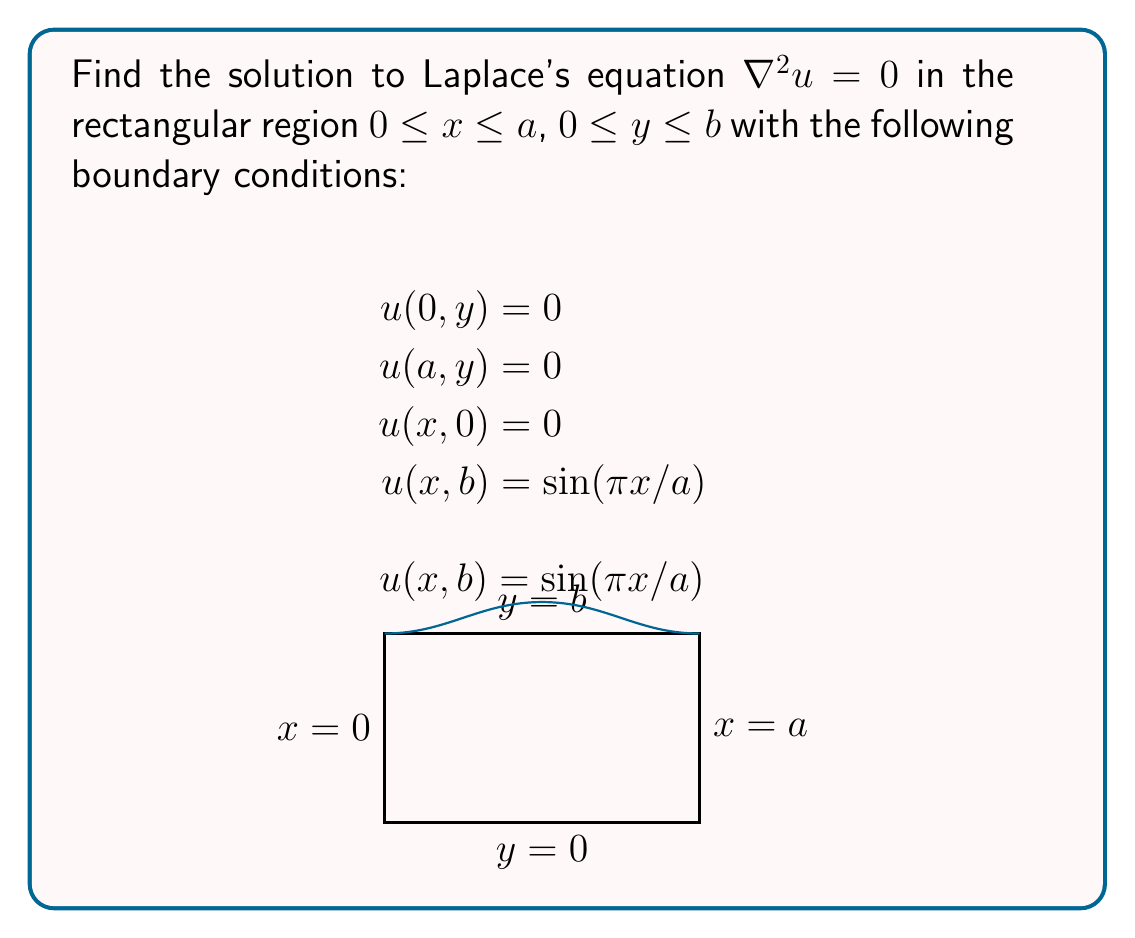Show me your answer to this math problem. 1) We use separation of variables, assuming $u(x,y) = X(x)Y(y)$.

2) Substituting into Laplace's equation:
   $$X''Y + XY'' = 0$$
   $$\frac{X''}{X} = -\frac{Y''}{Y} = -\lambda^2$$

3) This gives two ODEs:
   $$X'' + \lambda^2 X = 0$$
   $$Y'' - \lambda^2 Y = 0$$

4) The general solutions are:
   $$X(x) = A \sin(\lambda x) + B \cos(\lambda x)$$
   $$Y(y) = C e^{\lambda y} + D e^{-\lambda y}$$

5) Applying boundary conditions $u(0,y) = u(a,y) = 0$:
   $$B = 0$$ and $$\lambda_n = \frac{n\pi}{a}, n = 1,2,3,...$$

6) The solution becomes:
   $$u(x,y) = \sum_{n=1}^{\infty} (C_n e^{\lambda_n y} + D_n e^{-\lambda_n y}) \sin(\lambda_n x)$$

7) Applying $u(x,0) = 0$:
   $$C_n = -D_n$$

8) The solution simplifies to:
   $$u(x,y) = \sum_{n=1}^{\infty} A_n \sinh(\lambda_n y) \sin(\lambda_n x)$$

9) For the final condition $u(x,b) = \sin(\pi x/a)$:
   $$\sum_{n=1}^{\infty} A_n \sinh(\lambda_n b) \sin(\lambda_n x) = \sin(\pi x/a)$$

10) This implies $A_1 \sinh(\pi b/a) = 1$ and $A_n = 0$ for $n > 1$.

11) Therefore, the final solution is:
    $$u(x,y) = \frac{\sinh(\pi y/a)}{\sinh(\pi b/a)} \sin(\pi x/a)$$
Answer: $u(x,y) = \frac{\sinh(\pi y/a)}{\sinh(\pi b/a)} \sin(\pi x/a)$ 